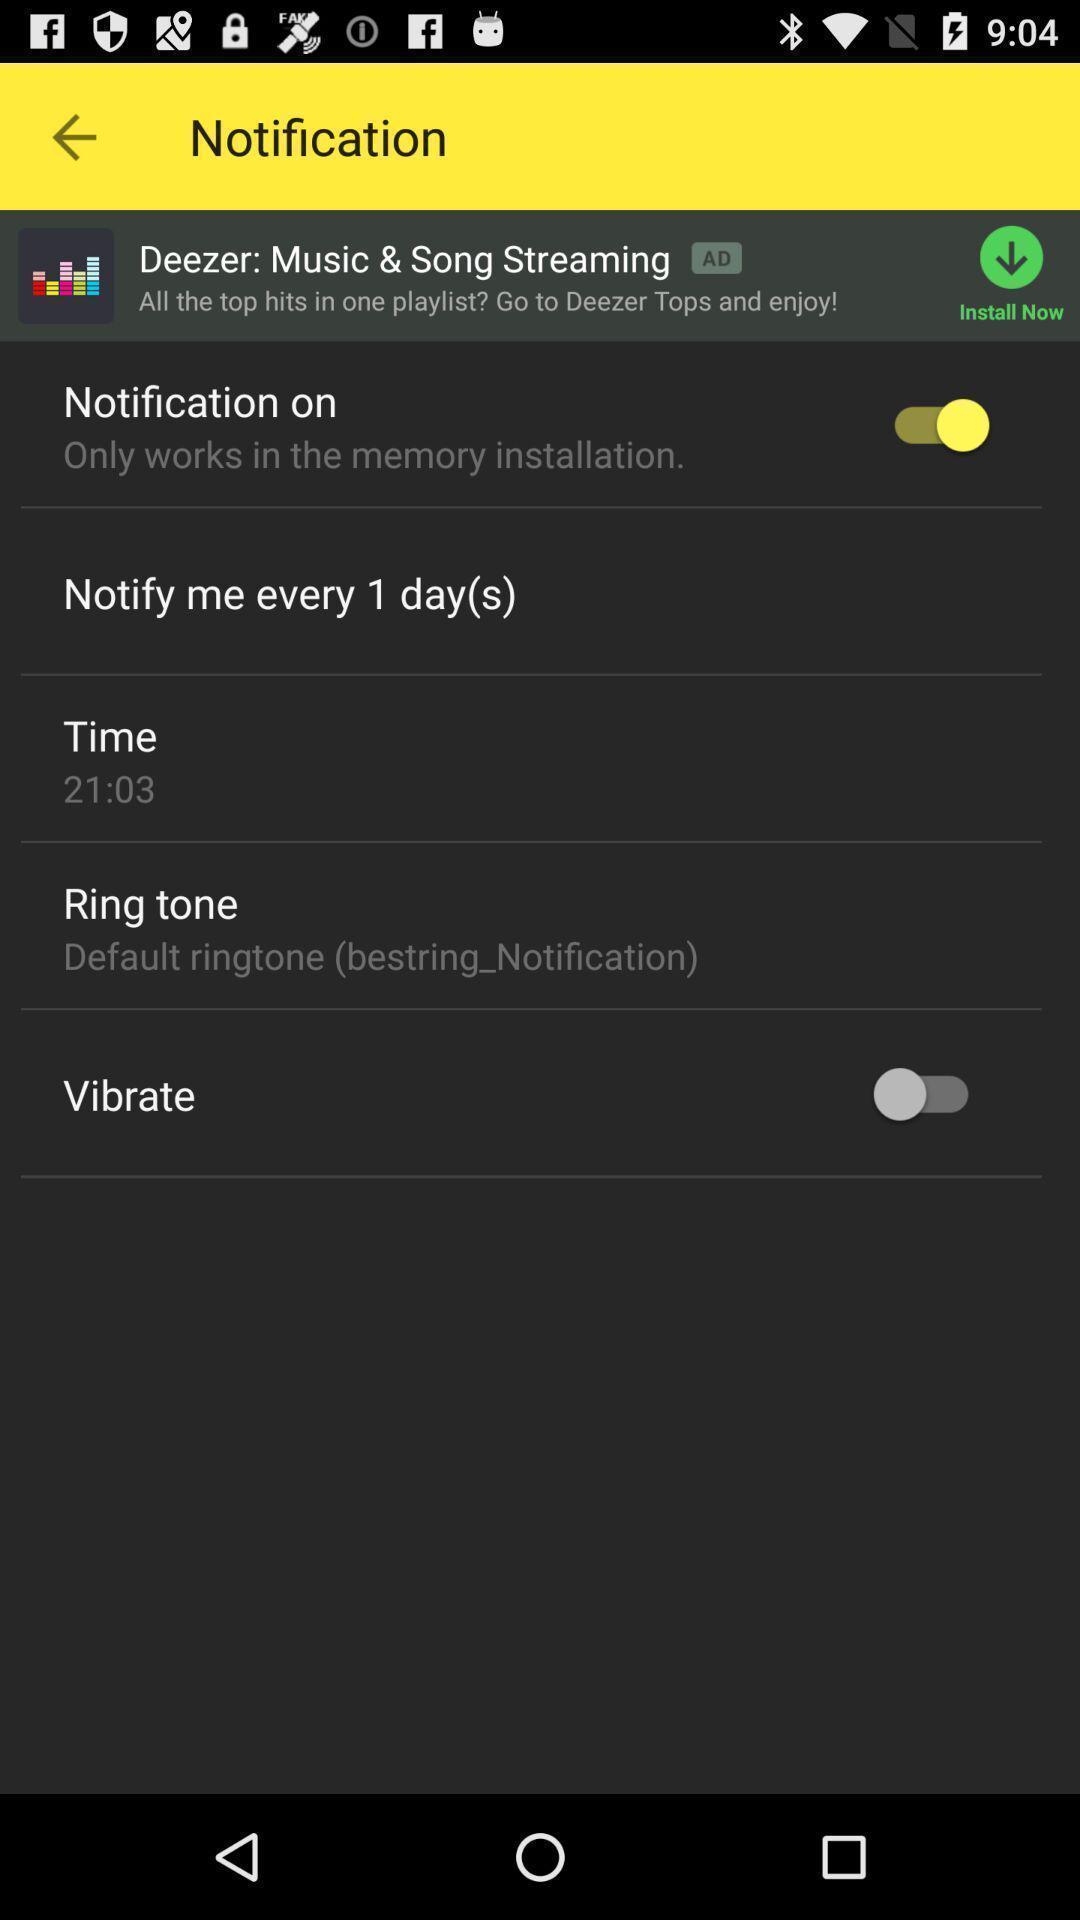Describe the content in this image. Settings page for setting notifications. 